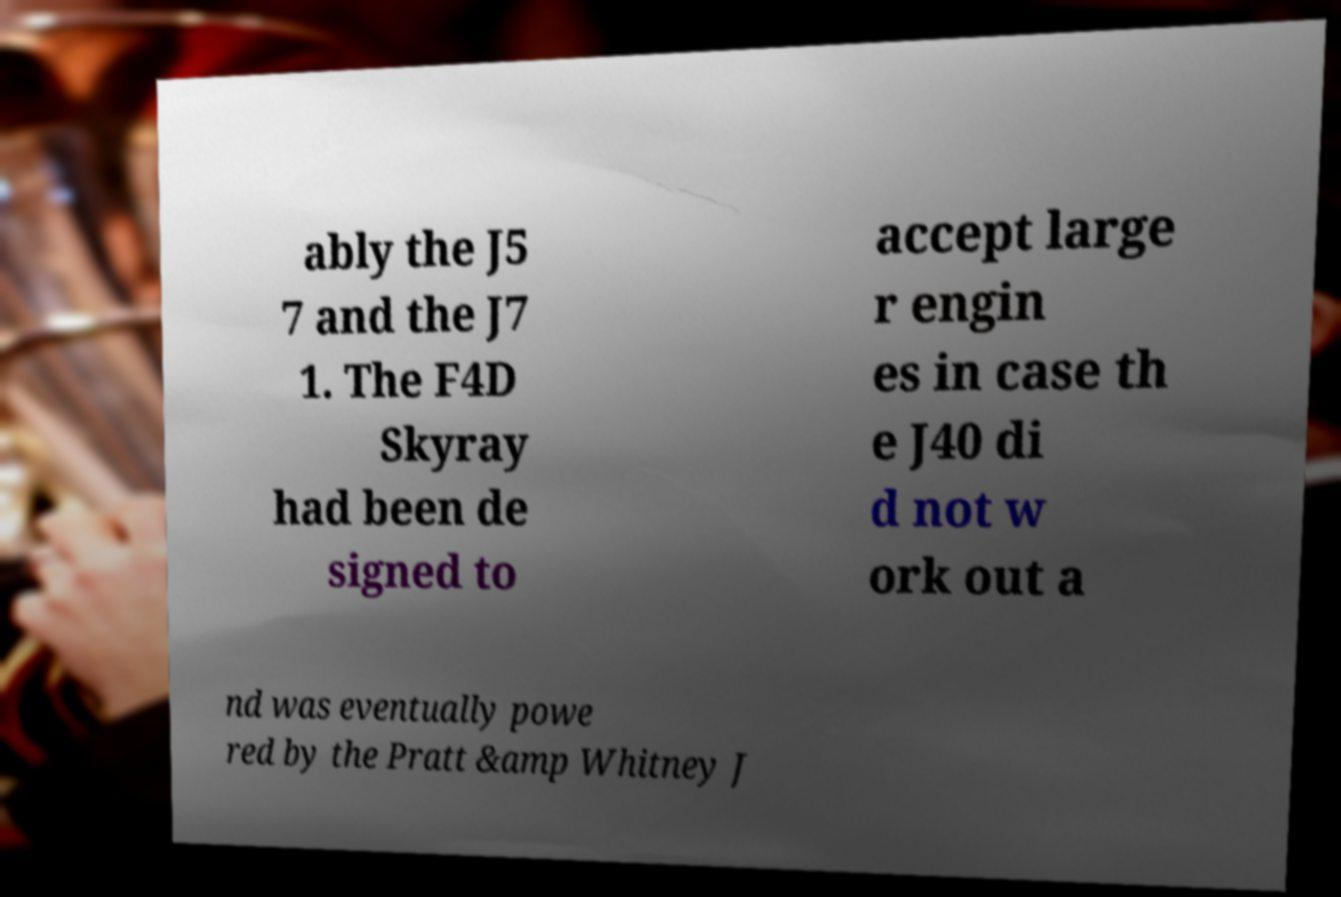Can you accurately transcribe the text from the provided image for me? ably the J5 7 and the J7 1. The F4D Skyray had been de signed to accept large r engin es in case th e J40 di d not w ork out a nd was eventually powe red by the Pratt &amp Whitney J 